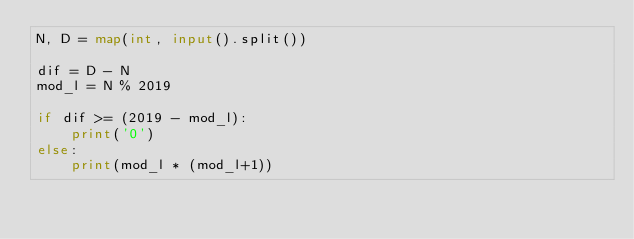<code> <loc_0><loc_0><loc_500><loc_500><_Python_>N, D = map(int, input().split())

dif = D - N
mod_l = N % 2019

if dif >= (2019 - mod_l):
    print('0')
else:
    print(mod_l * (mod_l+1))
</code> 